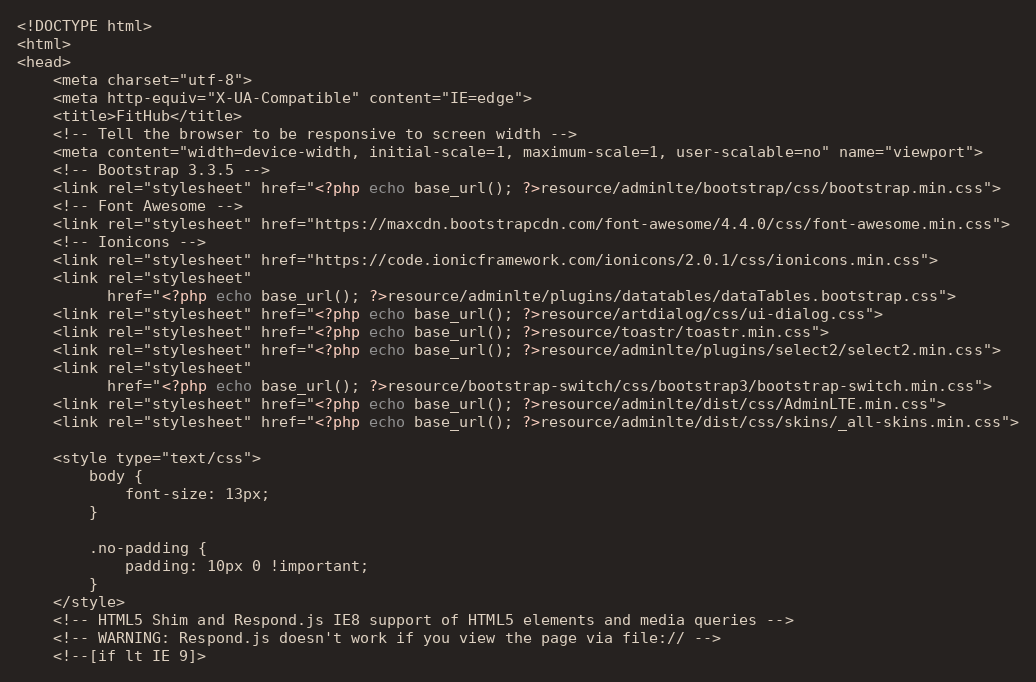Convert code to text. <code><loc_0><loc_0><loc_500><loc_500><_PHP_><!DOCTYPE html>
<html>
<head>
    <meta charset="utf-8">
    <meta http-equiv="X-UA-Compatible" content="IE=edge">
    <title>FitHub</title>
    <!-- Tell the browser to be responsive to screen width -->
    <meta content="width=device-width, initial-scale=1, maximum-scale=1, user-scalable=no" name="viewport">
    <!-- Bootstrap 3.3.5 -->
    <link rel="stylesheet" href="<?php echo base_url(); ?>resource/adminlte/bootstrap/css/bootstrap.min.css">
    <!-- Font Awesome -->
    <link rel="stylesheet" href="https://maxcdn.bootstrapcdn.com/font-awesome/4.4.0/css/font-awesome.min.css">
    <!-- Ionicons -->
    <link rel="stylesheet" href="https://code.ionicframework.com/ionicons/2.0.1/css/ionicons.min.css">
    <link rel="stylesheet"
          href="<?php echo base_url(); ?>resource/adminlte/plugins/datatables/dataTables.bootstrap.css">
    <link rel="stylesheet" href="<?php echo base_url(); ?>resource/artdialog/css/ui-dialog.css">
    <link rel="stylesheet" href="<?php echo base_url(); ?>resource/toastr/toastr.min.css">
    <link rel="stylesheet" href="<?php echo base_url(); ?>resource/adminlte/plugins/select2/select2.min.css">
    <link rel="stylesheet"
          href="<?php echo base_url(); ?>resource/bootstrap-switch/css/bootstrap3/bootstrap-switch.min.css">
    <link rel="stylesheet" href="<?php echo base_url(); ?>resource/adminlte/dist/css/AdminLTE.min.css">
    <link rel="stylesheet" href="<?php echo base_url(); ?>resource/adminlte/dist/css/skins/_all-skins.min.css">

    <style type="text/css">
        body {
            font-size: 13px;
        }

        .no-padding {
            padding: 10px 0 !important;
        }
    </style>
    <!-- HTML5 Shim and Respond.js IE8 support of HTML5 elements and media queries -->
    <!-- WARNING: Respond.js doesn't work if you view the page via file:// -->
    <!--[if lt IE 9]></code> 